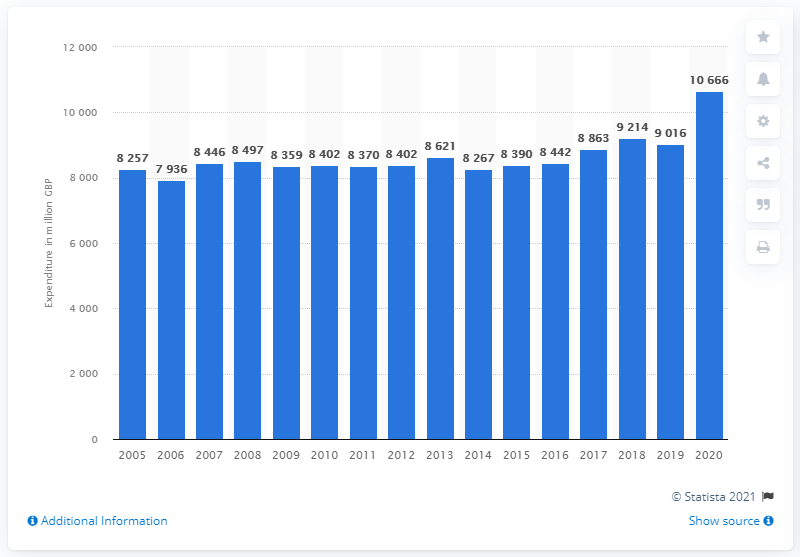Give some essential details in this illustration. In 2020, households in the UK purchased approximately 106,660 pounds worth of wine. 